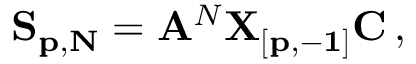Convert formula to latex. <formula><loc_0><loc_0><loc_500><loc_500>{ S _ { p , N } } = { A } ^ { N } { X _ { [ p , - 1 ] } C } \, ,</formula> 